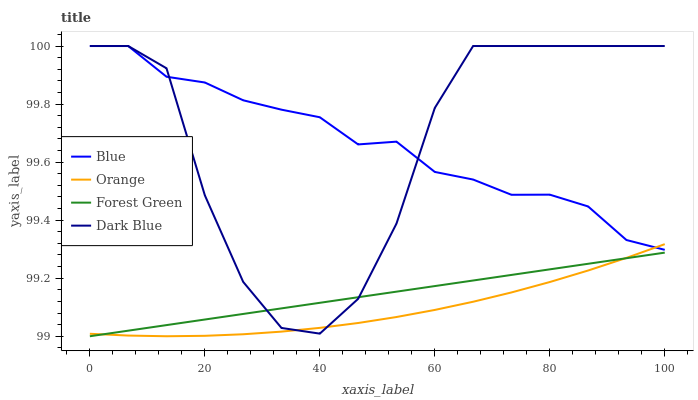Does Orange have the minimum area under the curve?
Answer yes or no. Yes. Does Blue have the maximum area under the curve?
Answer yes or no. Yes. Does Forest Green have the minimum area under the curve?
Answer yes or no. No. Does Forest Green have the maximum area under the curve?
Answer yes or no. No. Is Forest Green the smoothest?
Answer yes or no. Yes. Is Dark Blue the roughest?
Answer yes or no. Yes. Is Orange the smoothest?
Answer yes or no. No. Is Orange the roughest?
Answer yes or no. No. Does Forest Green have the lowest value?
Answer yes or no. Yes. Does Orange have the lowest value?
Answer yes or no. No. Does Dark Blue have the highest value?
Answer yes or no. Yes. Does Orange have the highest value?
Answer yes or no. No. Is Forest Green less than Blue?
Answer yes or no. Yes. Is Blue greater than Forest Green?
Answer yes or no. Yes. Does Dark Blue intersect Orange?
Answer yes or no. Yes. Is Dark Blue less than Orange?
Answer yes or no. No. Is Dark Blue greater than Orange?
Answer yes or no. No. Does Forest Green intersect Blue?
Answer yes or no. No. 